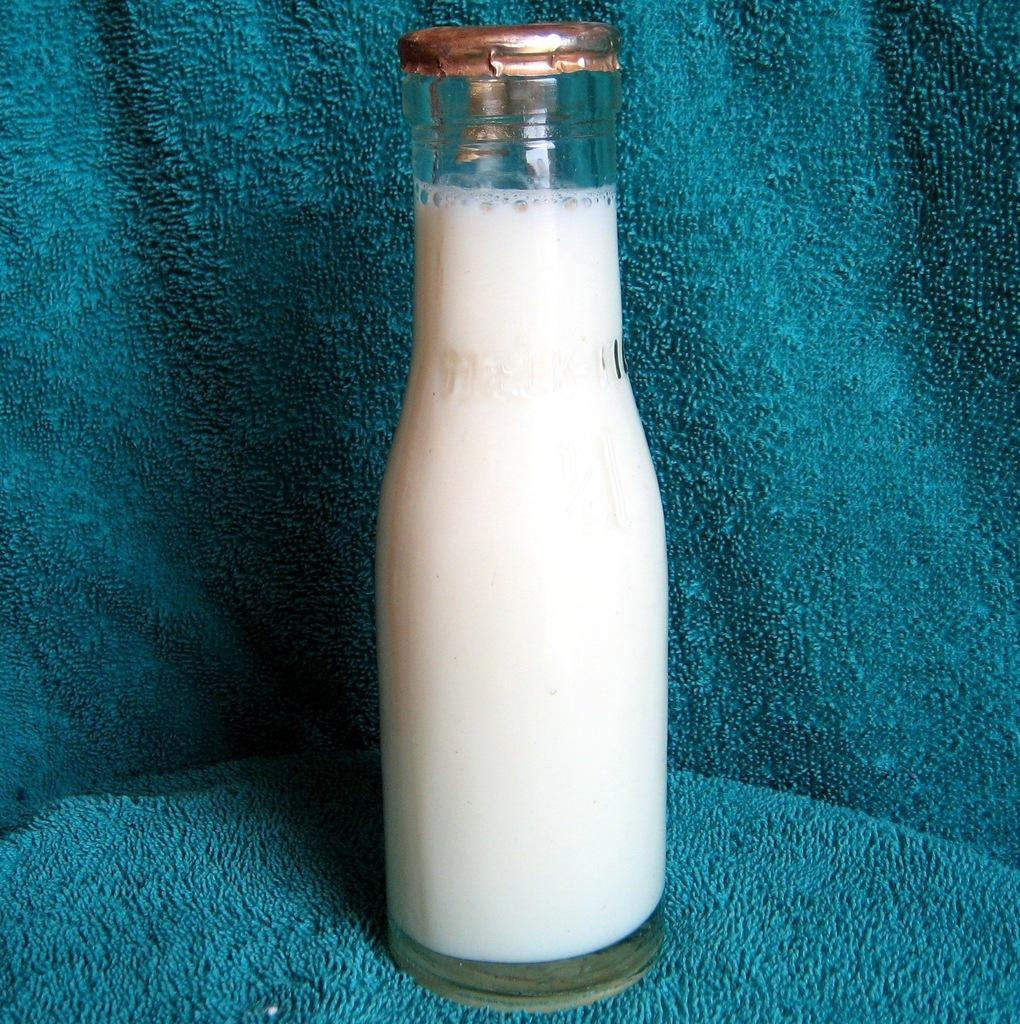What is the main object in the image? There is a milk bottle in the image. What is the milk bottle placed on? The milk bottle is on a blue cloth. How many dogs are supporting the milk bottle in the image? There are no dogs present in the image, and therefore no support is provided by dogs. 